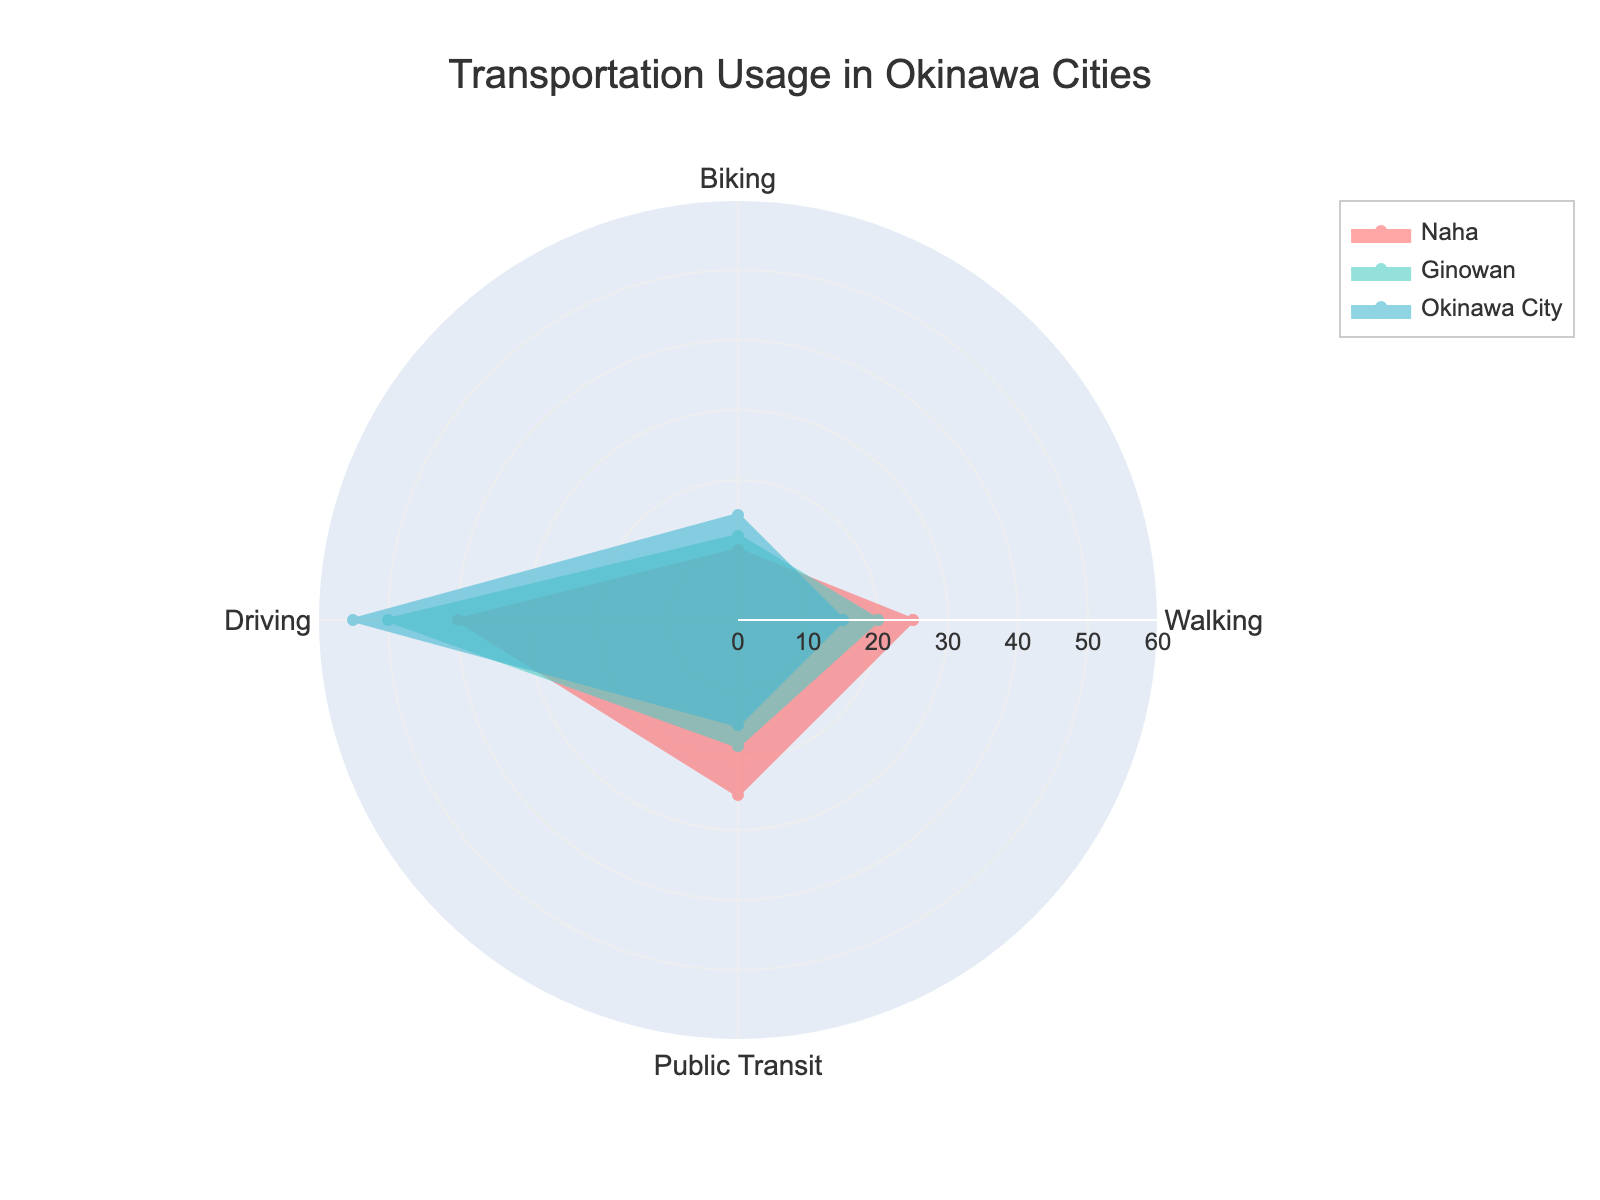What's the title of the radar chart? The title of the chart is usually placed at the top of the figure. In this case, the title reads "Transportation Usage in Okinawa Cities."
Answer: Transportation Usage in Okinawa Cities How many different groups are represented on the chart? By observing the legend or the different lines and colors on the radar chart, we can identify the number of groups. Here, there are three groups: "Naha," "Ginowan," and "Okinawa City."
Answer: 3 Which group has the highest value for Driving? To determine this, look at the 'Driving' axis and see which group's line extends the farthest. "Okinawa City" has the highest value for Driving, which is 55.
Answer: Okinawa City What is the sum of the values for Public Transit across all groups? Sum the Public Transit values provided: Naha (25) + Ginowan (18) + Okinawa City (15), which equals 58.
Answer: 58 Which group has the lowest value for Walking? By comparing the 'Walking' values on the radar chart, you can see that "Okinawa City" has the lowest value, which is 15.
Answer: Okinawa City Between Naha and Ginowan, which group has a higher value for Biking? Look at the 'Biking' values for both "Naha" and "Ginowan." Naha has 10, while Ginowan has 12, so Ginowan has a higher value.
Answer: Ginowan What is the average value for Walking across all groups? Add up the Walking values for all groups: (25 + 20 + 15) = 60, then divide by the number of groups, which is 3. So, the average is 60 / 3 = 20.
Answer: 20 Which mode of transportation has the most similar values across all three groups? By visually comparing the extent of lines for each transportation mode, "Biking" shows the most similar values across groups: 10, 12, and 15.
Answer: Biking What is the total value for Naha across all modes of transportation? Add up all transportation values for Naha: Walking (25) + Biking (10) + Driving (40) + Public Transit (25), which equals 100.
Answer: 100 Which group uses Public Transit the least? By comparing the values on the 'Public Transit' axis, "Okinawa City" has the lowest value, which is 15.
Answer: Okinawa City 